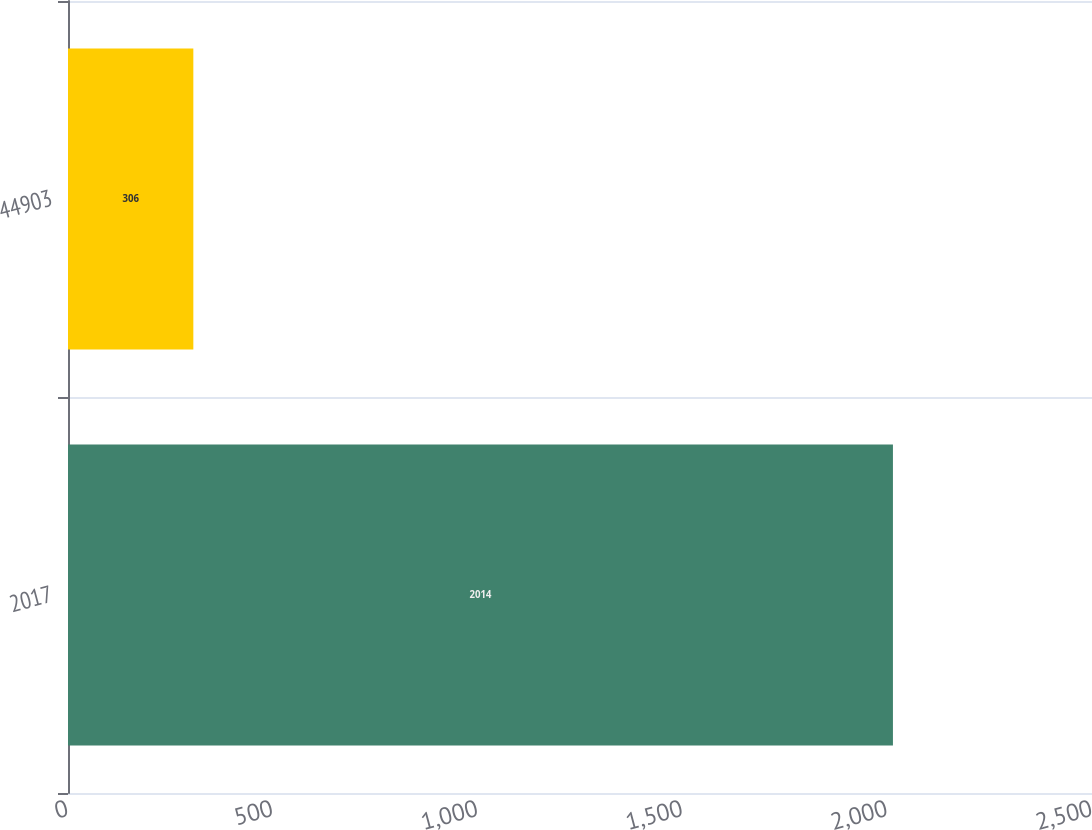<chart> <loc_0><loc_0><loc_500><loc_500><bar_chart><fcel>2017<fcel>44903<nl><fcel>2014<fcel>306<nl></chart> 